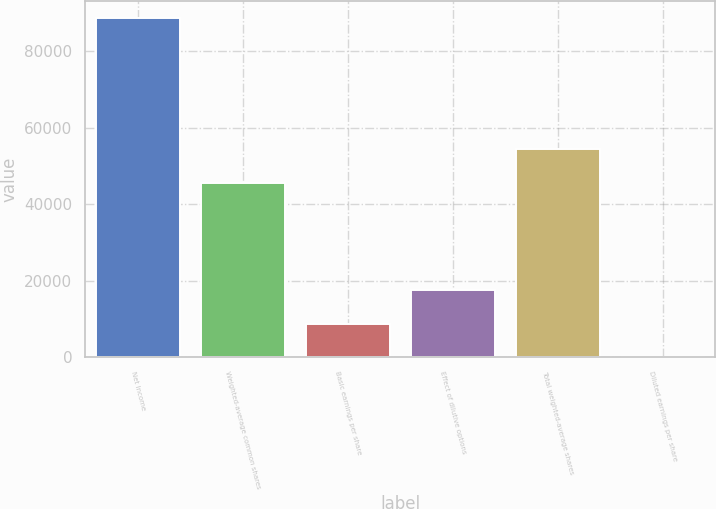Convert chart to OTSL. <chart><loc_0><loc_0><loc_500><loc_500><bar_chart><fcel>Net Income<fcel>Weighted-average common shares<fcel>Basic earnings per share<fcel>Effect of dilutive options<fcel>Total weighted-average shares<fcel>Diluted earnings per share<nl><fcel>88645<fcel>45630<fcel>8866.15<fcel>17730.5<fcel>54494.3<fcel>1.83<nl></chart> 